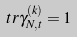Convert formula to latex. <formula><loc_0><loc_0><loc_500><loc_500>\ t r \gamma _ { N , t } ^ { ( k ) } = 1</formula> 